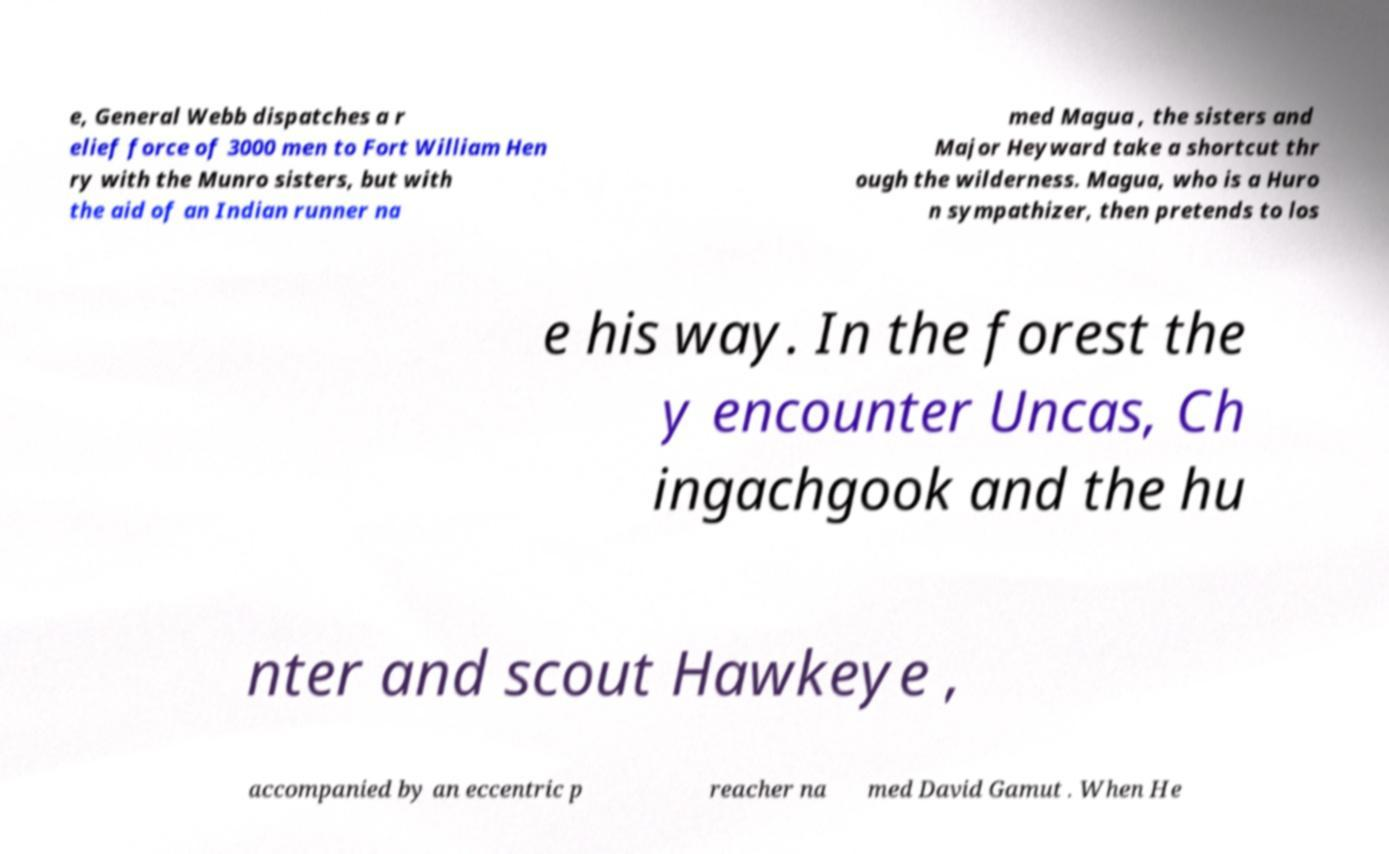Please identify and transcribe the text found in this image. e, General Webb dispatches a r elief force of 3000 men to Fort William Hen ry with the Munro sisters, but with the aid of an Indian runner na med Magua , the sisters and Major Heyward take a shortcut thr ough the wilderness. Magua, who is a Huro n sympathizer, then pretends to los e his way. In the forest the y encounter Uncas, Ch ingachgook and the hu nter and scout Hawkeye , accompanied by an eccentric p reacher na med David Gamut . When He 